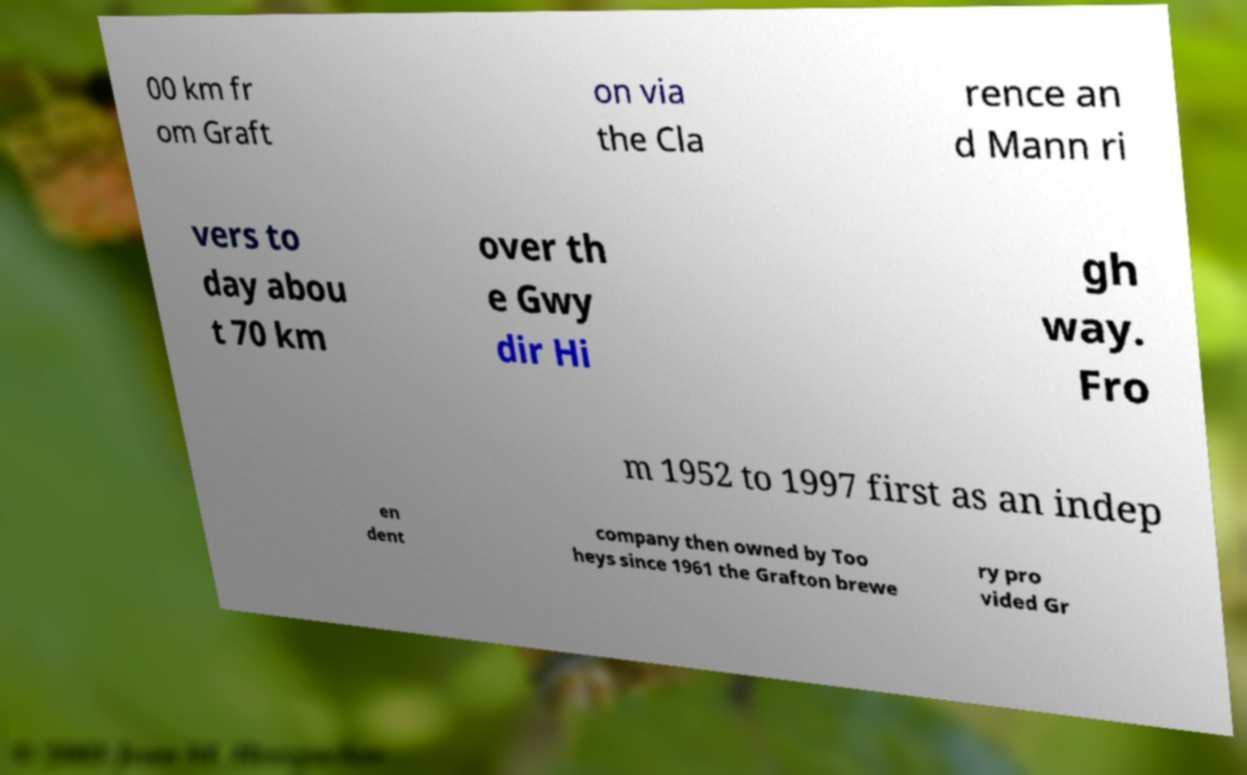For documentation purposes, I need the text within this image transcribed. Could you provide that? 00 km fr om Graft on via the Cla rence an d Mann ri vers to day abou t 70 km over th e Gwy dir Hi gh way. Fro m 1952 to 1997 first as an indep en dent company then owned by Too heys since 1961 the Grafton brewe ry pro vided Gr 